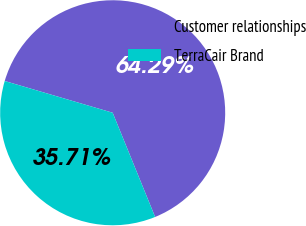<chart> <loc_0><loc_0><loc_500><loc_500><pie_chart><fcel>Customer relationships<fcel>TerraCair Brand<nl><fcel>64.29%<fcel>35.71%<nl></chart> 